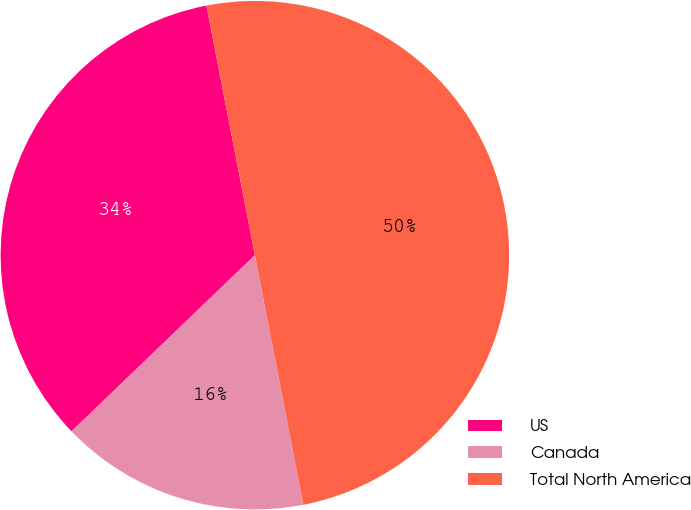Convert chart. <chart><loc_0><loc_0><loc_500><loc_500><pie_chart><fcel>US<fcel>Canada<fcel>Total North America<nl><fcel>34.13%<fcel>15.87%<fcel>50.0%<nl></chart> 